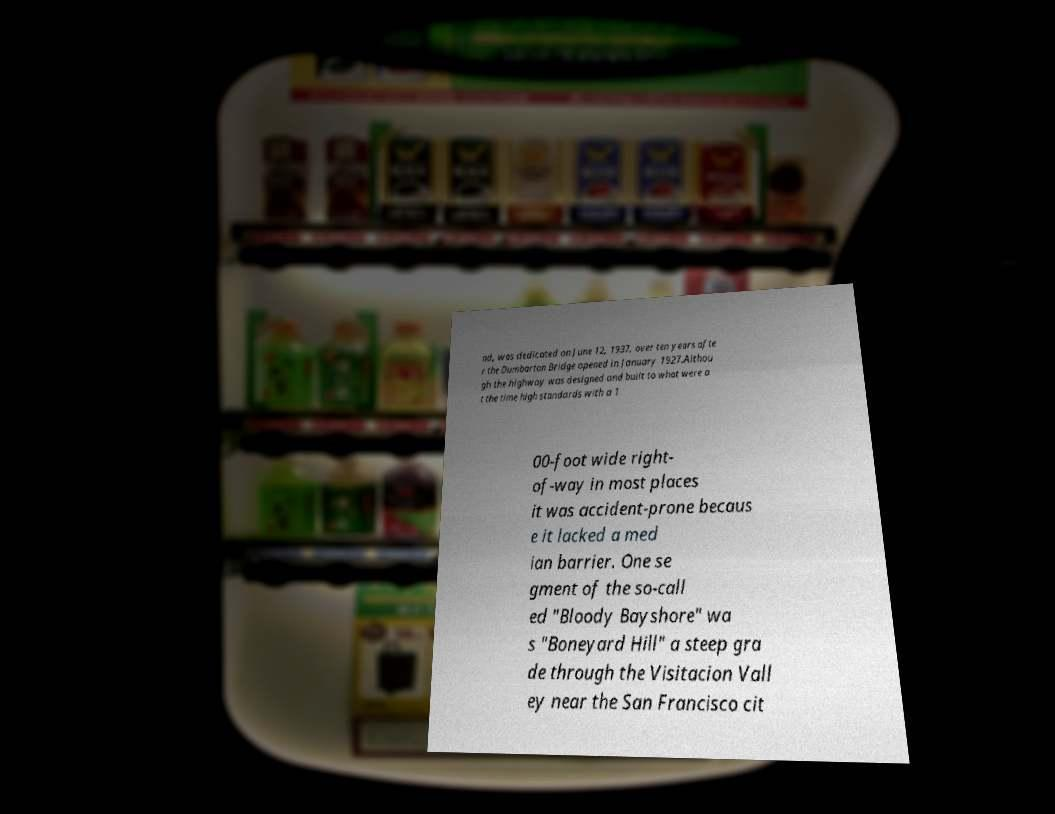Could you extract and type out the text from this image? nd, was dedicated on June 12, 1937, over ten years afte r the Dumbarton Bridge opened in January 1927.Althou gh the highway was designed and built to what were a t the time high standards with a 1 00-foot wide right- of-way in most places it was accident-prone becaus e it lacked a med ian barrier. One se gment of the so-call ed "Bloody Bayshore" wa s "Boneyard Hill" a steep gra de through the Visitacion Vall ey near the San Francisco cit 